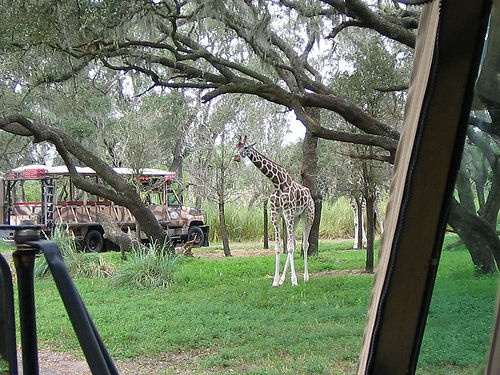Describe the objects in this image and their specific colors. I can see truck in gray, darkgray, black, and white tones, bus in gray, darkgray, black, and white tones, giraffe in gray, lightgray, darkgray, and black tones, and giraffe in gray, ivory, and darkgray tones in this image. 